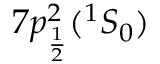Convert formula to latex. <formula><loc_0><loc_0><loc_500><loc_500>7 p _ { \frac { 1 } { 2 } } ^ { 2 } ( ^ { 1 } S _ { 0 } )</formula> 